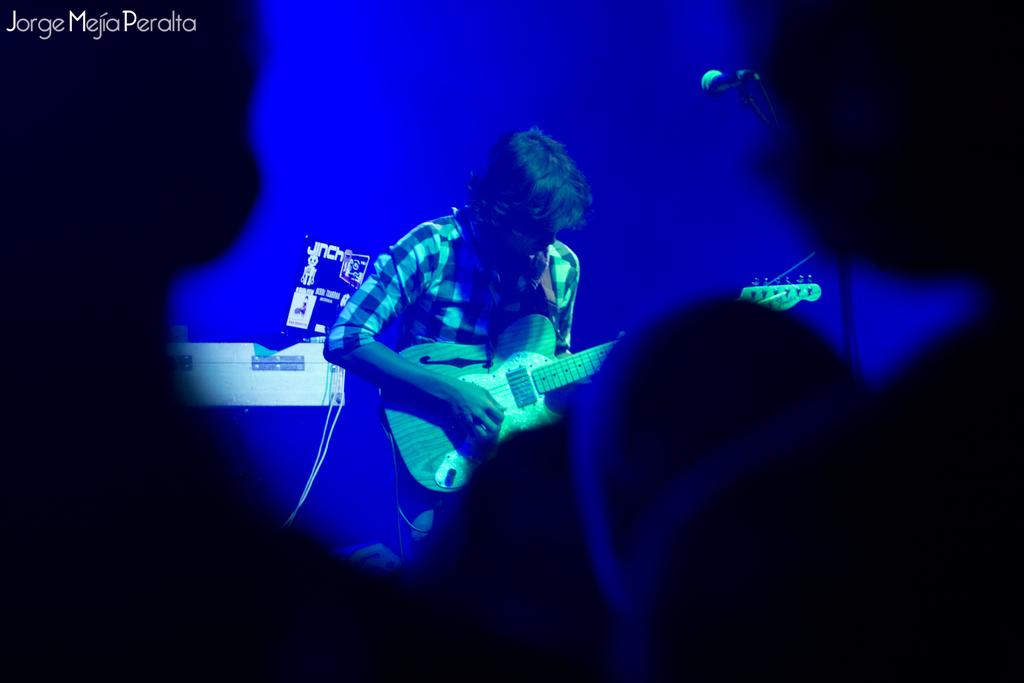What is happening at the bottom of the image? There are people standing at the bottom of the image. What is the man in the middle of the image doing? The man is standing in the middle of the image and holding a guitar. What object is present in the image that is typically used for amplifying sound? There is a microphone in the image. What type of watch is the man wearing in the image? There is no watch visible on the man in the image. Is there a bottle of water on the stage with the man and the microphone? There is no bottle of water mentioned or visible in the image. 